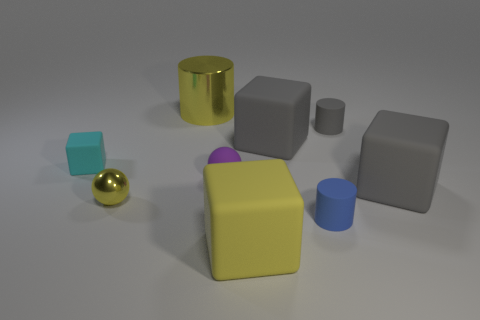Subtract all cylinders. How many objects are left? 6 Subtract all big rubber cylinders. Subtract all small cyan matte objects. How many objects are left? 8 Add 4 purple matte things. How many purple matte things are left? 5 Add 6 cyan rubber objects. How many cyan rubber objects exist? 7 Subtract 0 purple cylinders. How many objects are left? 9 